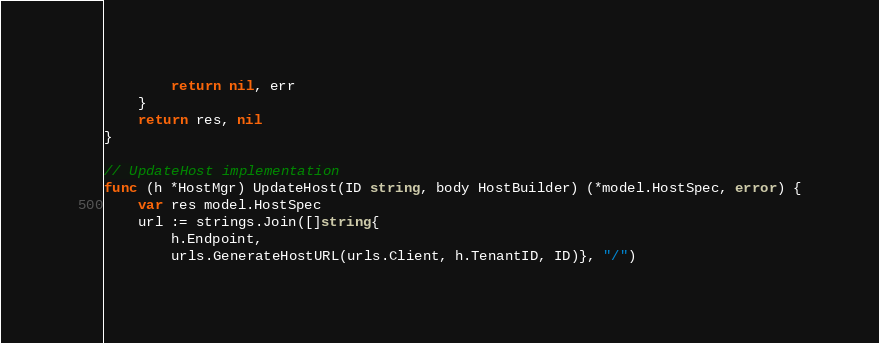<code> <loc_0><loc_0><loc_500><loc_500><_Go_>		return nil, err
	}
	return res, nil
}

// UpdateHost implementation
func (h *HostMgr) UpdateHost(ID string, body HostBuilder) (*model.HostSpec, error) {
	var res model.HostSpec
	url := strings.Join([]string{
		h.Endpoint,
		urls.GenerateHostURL(urls.Client, h.TenantID, ID)}, "/")
</code> 